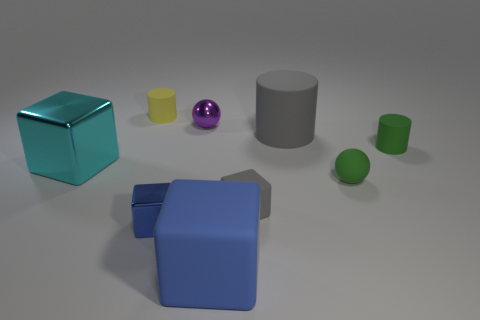How many other objects are there of the same color as the small matte block?
Give a very brief answer. 1. There is a green object that is in front of the small green matte thing that is behind the green matte ball in front of the cyan metal block; what is it made of?
Provide a short and direct response. Rubber. The small ball right of the small cube on the right side of the tiny purple metallic object is made of what material?
Provide a short and direct response. Rubber. Are there fewer gray matte cylinders to the right of the green ball than blue rubber cylinders?
Provide a succinct answer. No. What is the shape of the small green rubber thing behind the large cyan metallic object?
Ensure brevity in your answer.  Cylinder. There is a blue shiny thing; does it have the same size as the purple shiny ball on the right side of the small yellow cylinder?
Ensure brevity in your answer.  Yes. Are there any small blue objects made of the same material as the big cylinder?
Keep it short and to the point. No. How many blocks are green metallic objects or gray things?
Your response must be concise. 1. Is there a gray matte cube that is on the left side of the tiny sphere that is behind the big cyan cube?
Offer a terse response. No. Is the number of small things less than the number of metal blocks?
Give a very brief answer. No. 